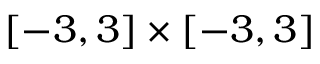<formula> <loc_0><loc_0><loc_500><loc_500>[ - 3 , 3 ] \times [ - 3 , 3 ]</formula> 